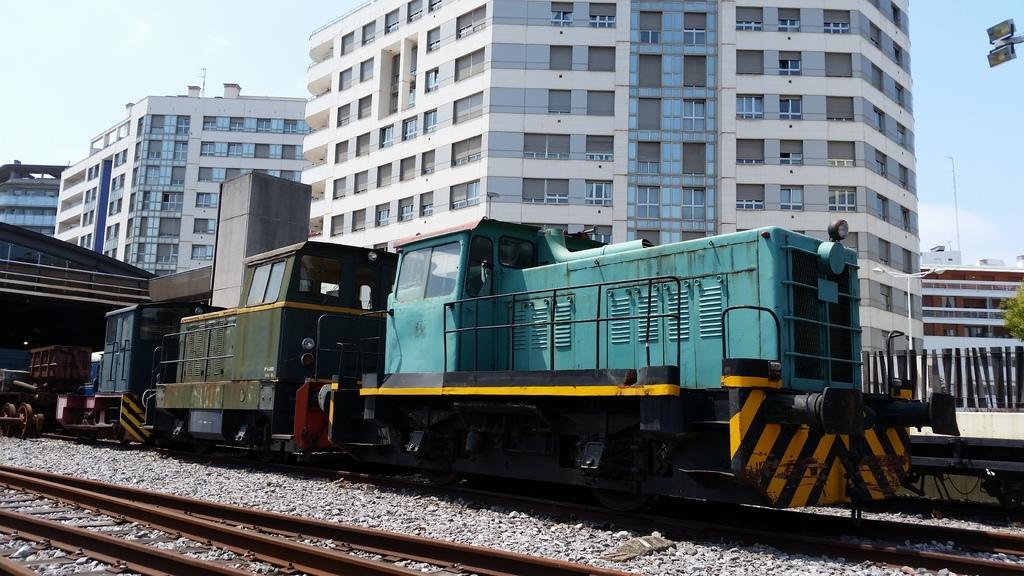Can you describe this image briefly? In the image there is a train on the railway track and behind the train there are tall buildings, there are a lot of windows to those buildings. 